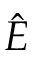Convert formula to latex. <formula><loc_0><loc_0><loc_500><loc_500>\hat { \boldsymbol E }</formula> 